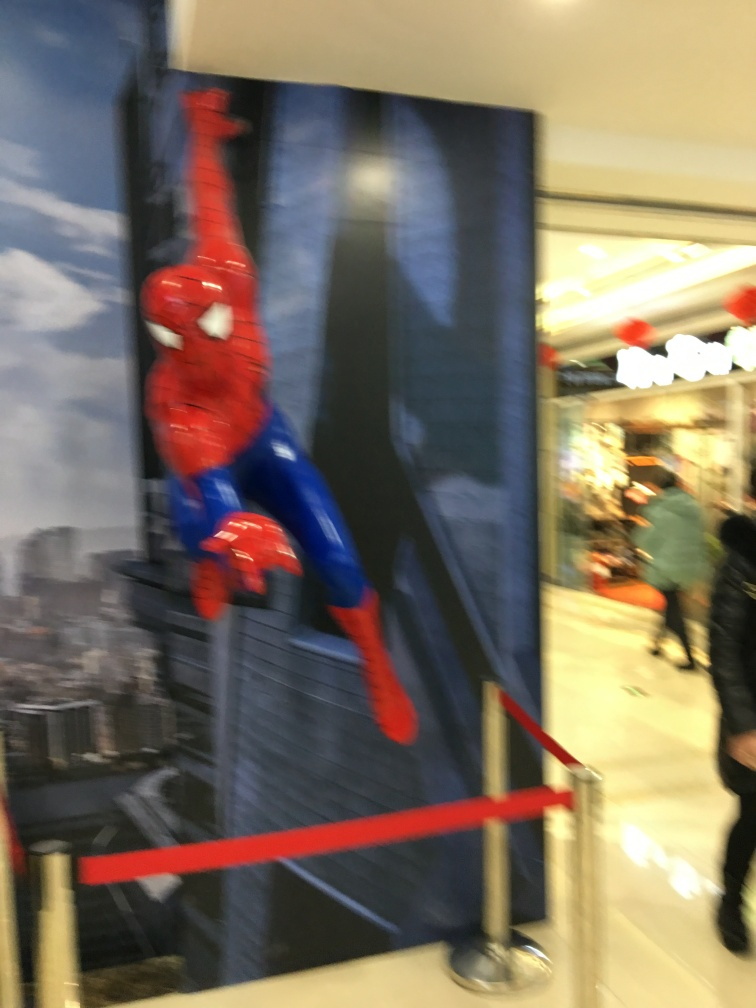Is the lighting of the image weak? The lighting in the image is moderately low, which can be observed from the less vibrant colors and the slight shadows. This may be due to the indoor setting and the nature of the photograph, which appears to be taken without a strong external light source or with a motion blur effect. 